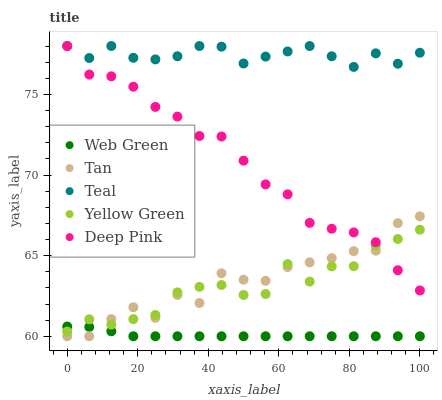Does Web Green have the minimum area under the curve?
Answer yes or no. Yes. Does Teal have the maximum area under the curve?
Answer yes or no. Yes. Does Deep Pink have the minimum area under the curve?
Answer yes or no. No. Does Deep Pink have the maximum area under the curve?
Answer yes or no. No. Is Web Green the smoothest?
Answer yes or no. Yes. Is Tan the roughest?
Answer yes or no. Yes. Is Deep Pink the smoothest?
Answer yes or no. No. Is Deep Pink the roughest?
Answer yes or no. No. Does Tan have the lowest value?
Answer yes or no. Yes. Does Deep Pink have the lowest value?
Answer yes or no. No. Does Teal have the highest value?
Answer yes or no. Yes. Does Web Green have the highest value?
Answer yes or no. No. Is Web Green less than Deep Pink?
Answer yes or no. Yes. Is Teal greater than Tan?
Answer yes or no. Yes. Does Deep Pink intersect Teal?
Answer yes or no. Yes. Is Deep Pink less than Teal?
Answer yes or no. No. Is Deep Pink greater than Teal?
Answer yes or no. No. Does Web Green intersect Deep Pink?
Answer yes or no. No. 